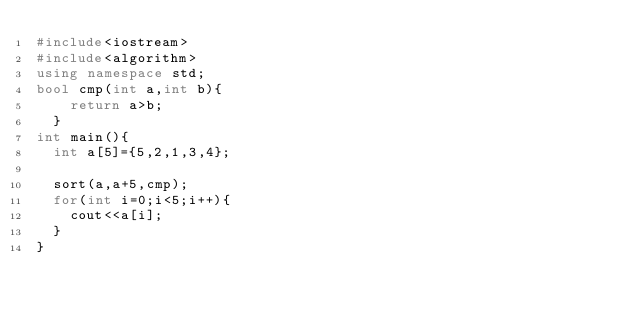<code> <loc_0><loc_0><loc_500><loc_500><_C++_>#include<iostream>
#include<algorithm>
using namespace std;
bool cmp(int a,int b){
    return a>b;
  }
int main(){
  int a[5]={5,2,1,3,4};
  
  sort(a,a+5,cmp);
  for(int i=0;i<5;i++){
    cout<<a[i];
  }
}</code> 